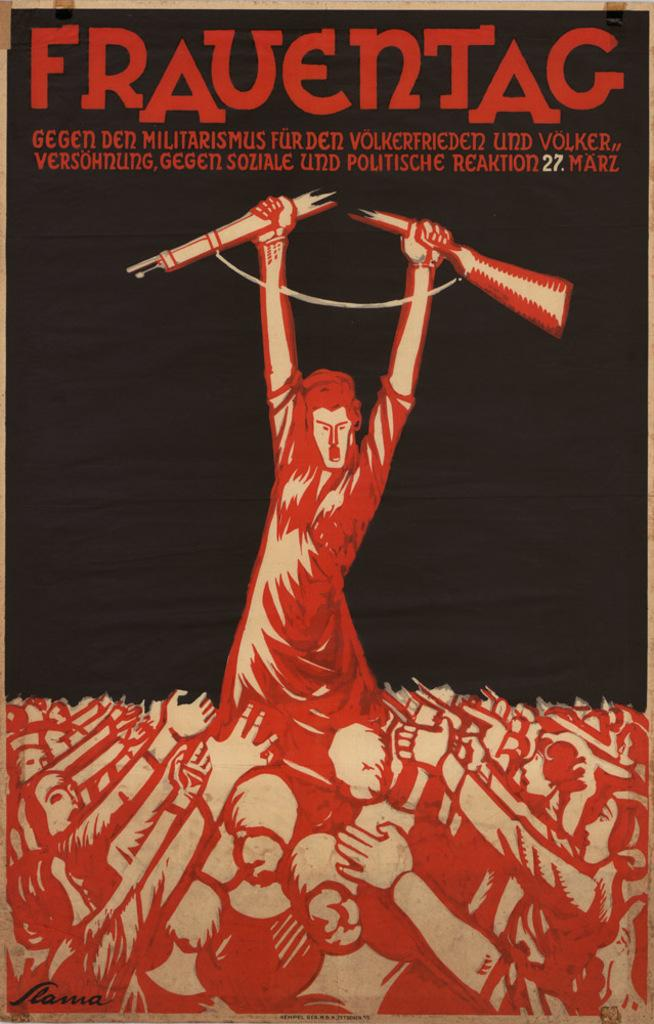<image>
Offer a succinct explanation of the picture presented. A man with two utensils in his hand entitled Frauentac. 